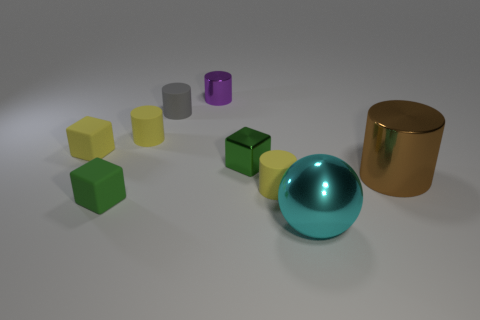Subtract all small gray matte cylinders. How many cylinders are left? 4 Subtract all purple cylinders. How many cylinders are left? 4 Subtract all cyan cylinders. Subtract all cyan cubes. How many cylinders are left? 5 Subtract all cylinders. How many objects are left? 4 Add 5 tiny yellow matte blocks. How many tiny yellow matte blocks are left? 6 Add 4 big red metal cubes. How many big red metal cubes exist? 4 Subtract 0 purple blocks. How many objects are left? 9 Subtract all cyan metal balls. Subtract all small green objects. How many objects are left? 6 